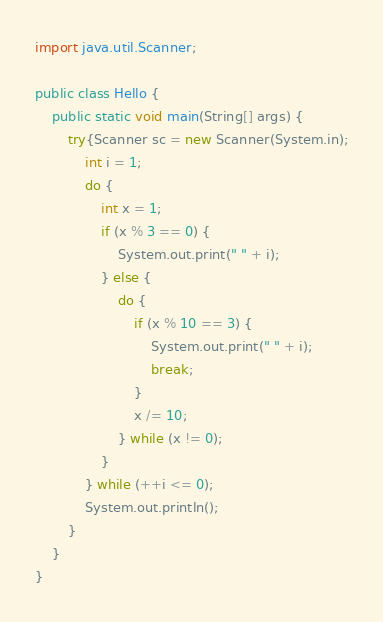Convert code to text. <code><loc_0><loc_0><loc_500><loc_500><_Java_>import java.util.Scanner;

public class Hello {
	public static void main(String[] args) {
		try{Scanner sc = new Scanner(System.in);
			int i = 1;
			do {
				int x = 1;
				if (x % 3 == 0) {
					System.out.print(" " + i);
				} else {
					do {
						if (x % 10 == 3) {
							System.out.print(" " + i);
							break;
						}
						x /= 10;
					} while (x != 0);
				}
			} while (++i <= 0);
			System.out.println();
		}
	}
}</code> 